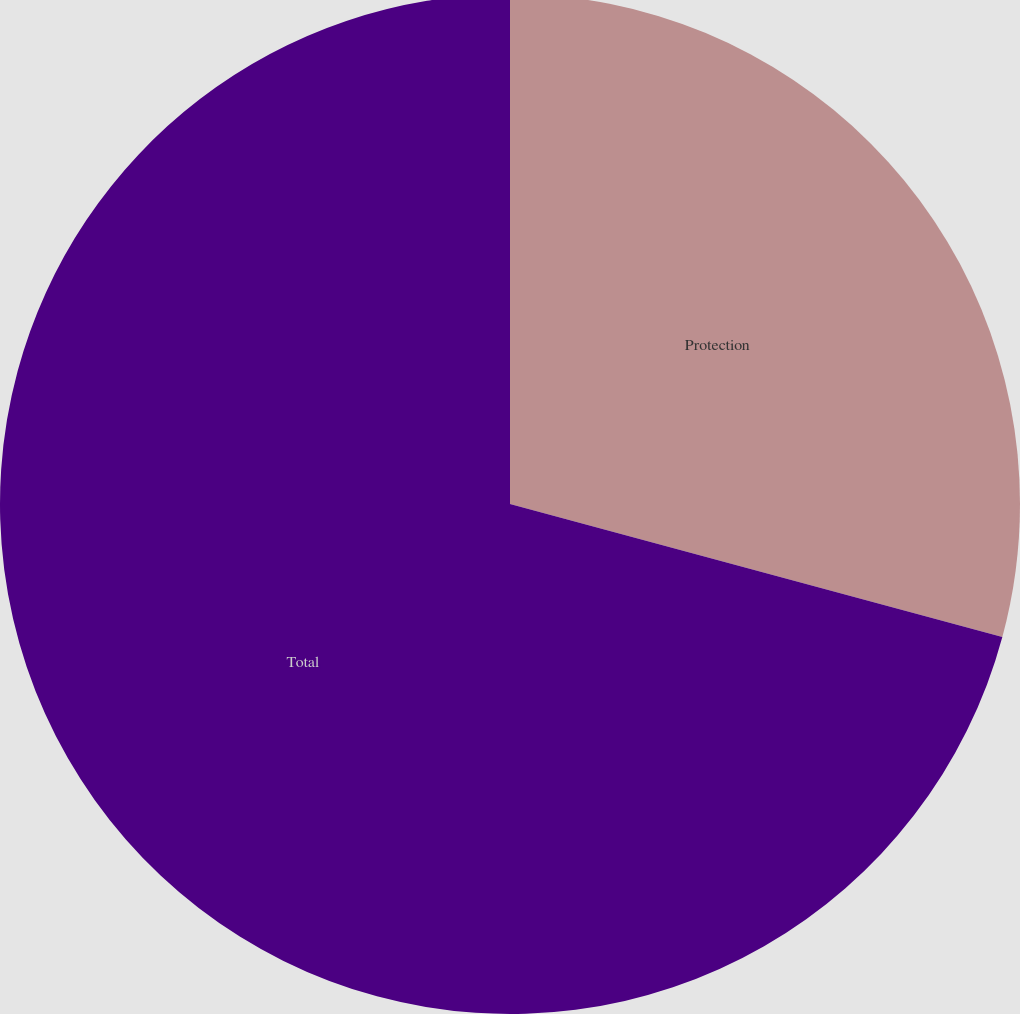<chart> <loc_0><loc_0><loc_500><loc_500><pie_chart><fcel>Protection<fcel>Total<nl><fcel>29.2%<fcel>70.8%<nl></chart> 